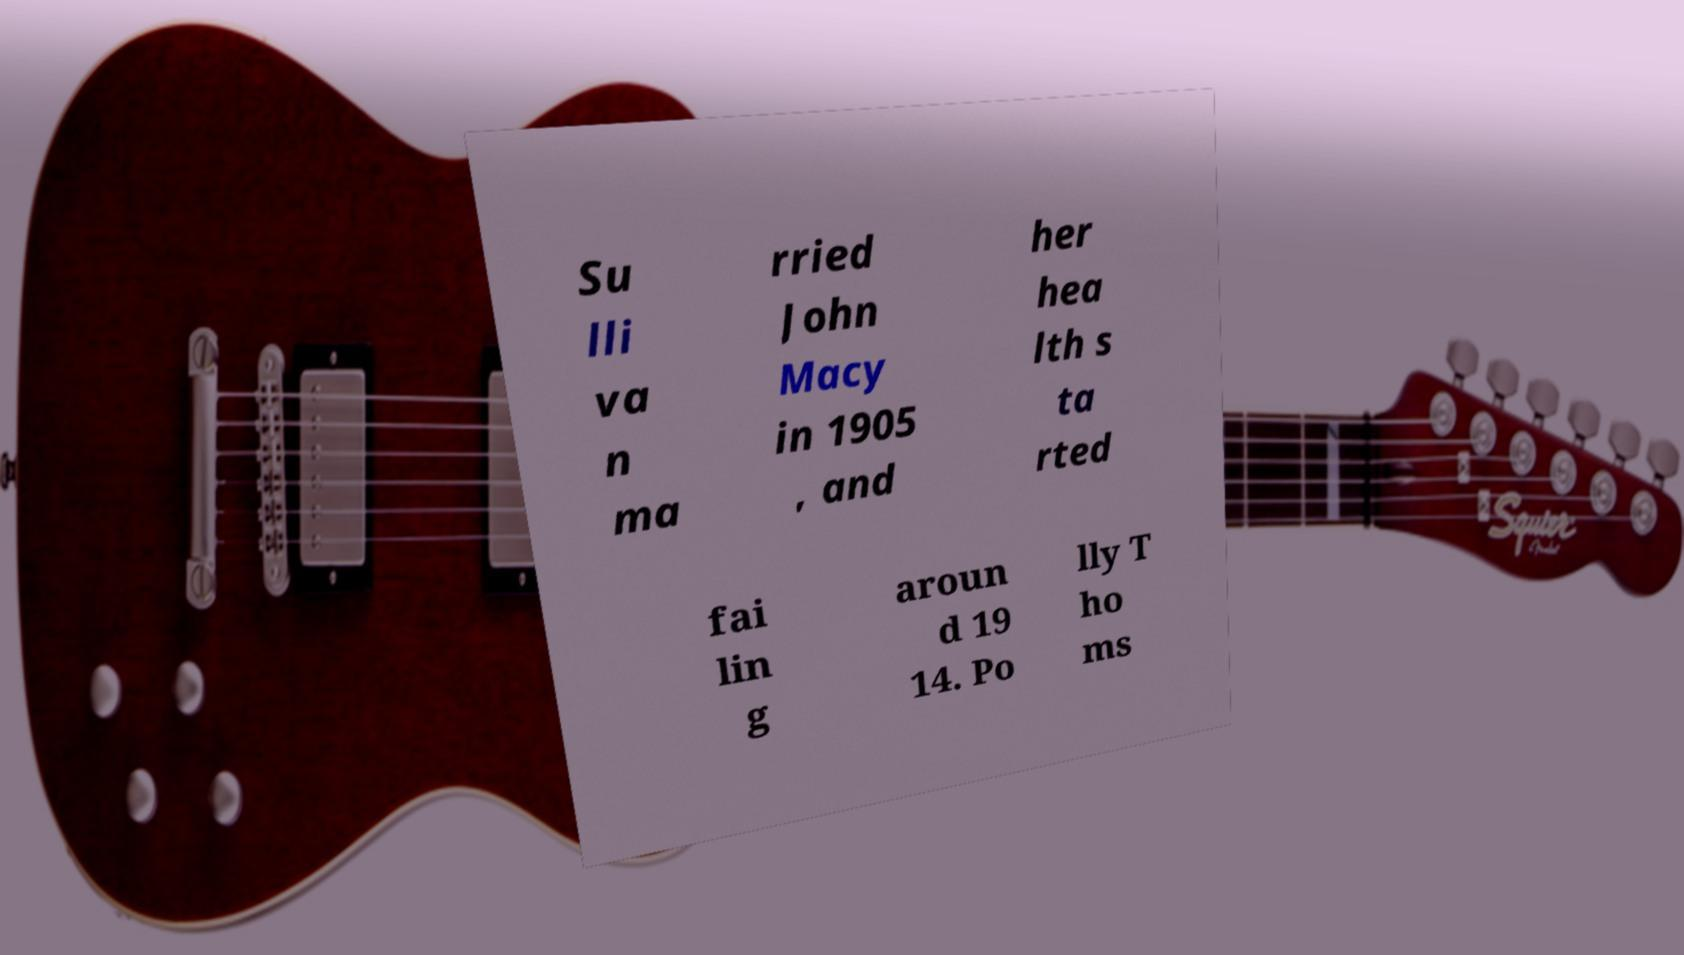For documentation purposes, I need the text within this image transcribed. Could you provide that? Su lli va n ma rried John Macy in 1905 , and her hea lth s ta rted fai lin g aroun d 19 14. Po lly T ho ms 